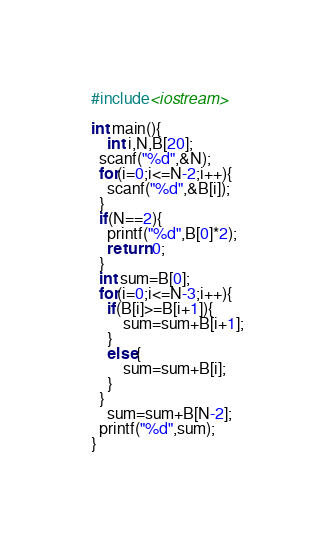<code> <loc_0><loc_0><loc_500><loc_500><_C++_>#include<iostream>

int main(){
	int i,N,B[20];
  scanf("%d",&N);
  for(i=0;i<=N-2;i++){
  	scanf("%d",&B[i]);
  }
  if(N==2){
    printf("%d",B[0]*2);
    return 0;
  }
  int sum=B[0];
  for(i=0;i<=N-3;i++){
  	if(B[i]>=B[i+1]){
    	sum=sum+B[i+1];
    }
    else{
    	sum=sum+B[i];
    }
  }
  	sum=sum+B[N-2];
  printf("%d",sum);
}</code> 